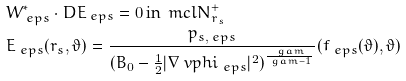Convert formula to latex. <formula><loc_0><loc_0><loc_500><loc_500>& W ^ { * } _ { \ e p s } \cdot D E _ { \ e p s } = 0 \, \text {in} \, \ m c l { N } ^ { + } _ { r _ { s } } \\ & E _ { \ e p s } ( r _ { s } , \vartheta ) = \frac { p _ { s , \ e p s } } { ( B _ { 0 } - \frac { 1 } { 2 } | \nabla \ v p h i _ { \ e p s } | ^ { 2 } ) ^ { \frac { \ g a m } { \ g a m - 1 } } } ( f _ { \ e p s } ( \vartheta ) , \vartheta )</formula> 